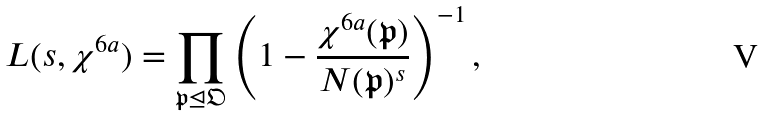Convert formula to latex. <formula><loc_0><loc_0><loc_500><loc_500>L ( s , \chi ^ { 6 a } ) = \prod _ { \mathfrak { p } \unlhd \mathfrak { O } } \left ( 1 - \frac { \chi ^ { 6 a } ( \mathfrak { p } ) } { N ( \mathfrak { p } ) ^ { s } } \right ) ^ { - 1 } ,</formula> 